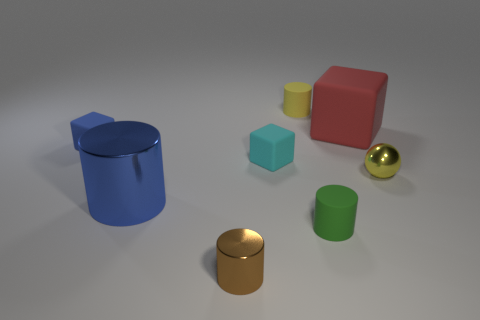What number of things are tiny purple shiny things or small matte objects behind the small yellow metal object?
Offer a very short reply. 3. What is the size of the brown cylinder that is the same material as the sphere?
Your answer should be very brief. Small. Is the number of green cylinders that are in front of the small metal cylinder greater than the number of tiny red cylinders?
Give a very brief answer. No. How big is the object that is both to the right of the yellow matte object and in front of the large blue shiny cylinder?
Provide a short and direct response. Small. There is a yellow thing that is the same shape as the brown object; what is its material?
Your answer should be very brief. Rubber. There is a cube that is on the left side of the brown metallic cylinder; does it have the same size as the yellow shiny thing?
Provide a succinct answer. Yes. What color is the thing that is both right of the tiny green matte cylinder and behind the tiny blue thing?
Keep it short and to the point. Red. What number of things are on the left side of the cylinder that is in front of the green cylinder?
Keep it short and to the point. 2. Do the big red rubber thing and the tiny yellow matte object have the same shape?
Keep it short and to the point. No. Is there any other thing that has the same color as the tiny metallic cylinder?
Keep it short and to the point. No. 